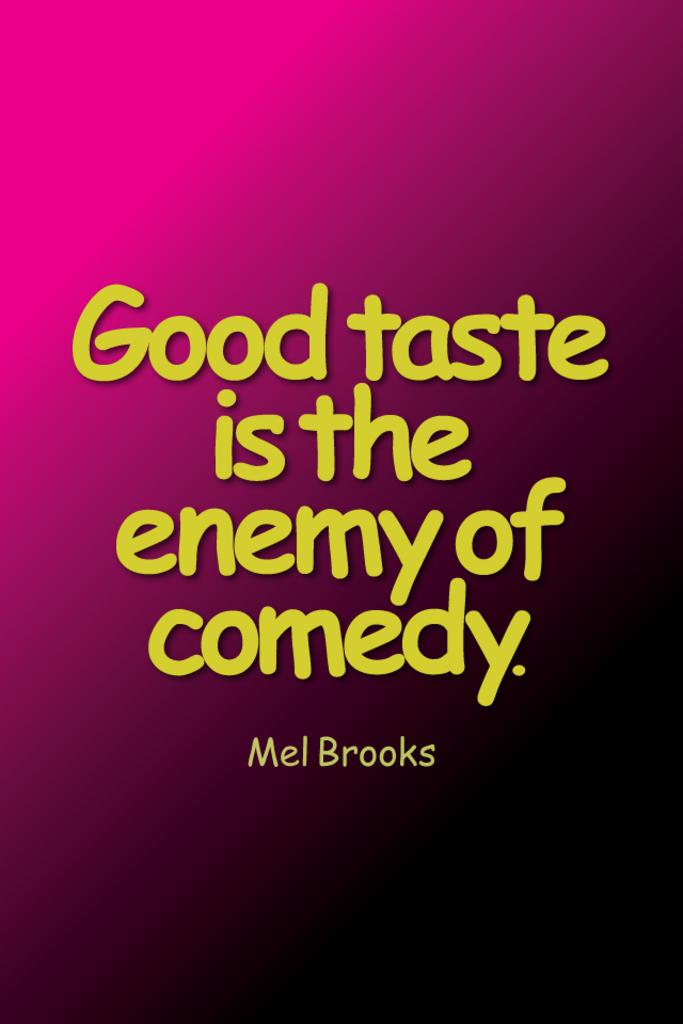<image>
Present a compact description of the photo's key features. a saying by mel brooks is good taste is the enemy of comedy 